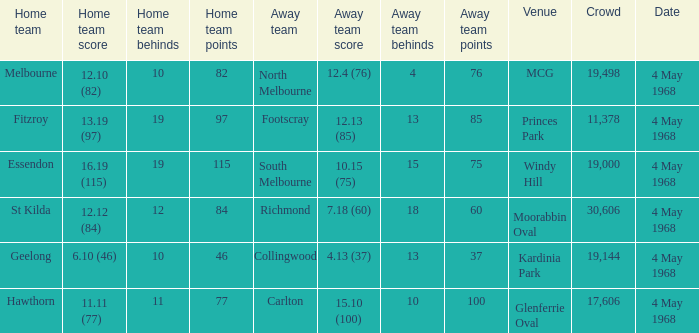What team played at Moorabbin Oval to a crowd of 19,144? St Kilda. 